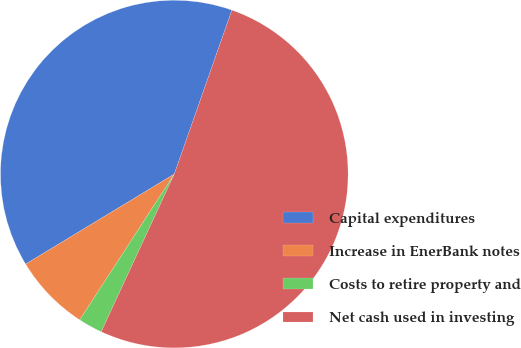Convert chart. <chart><loc_0><loc_0><loc_500><loc_500><pie_chart><fcel>Capital expenditures<fcel>Increase in EnerBank notes<fcel>Costs to retire property and<fcel>Net cash used in investing<nl><fcel>39.05%<fcel>7.18%<fcel>2.25%<fcel>51.53%<nl></chart> 